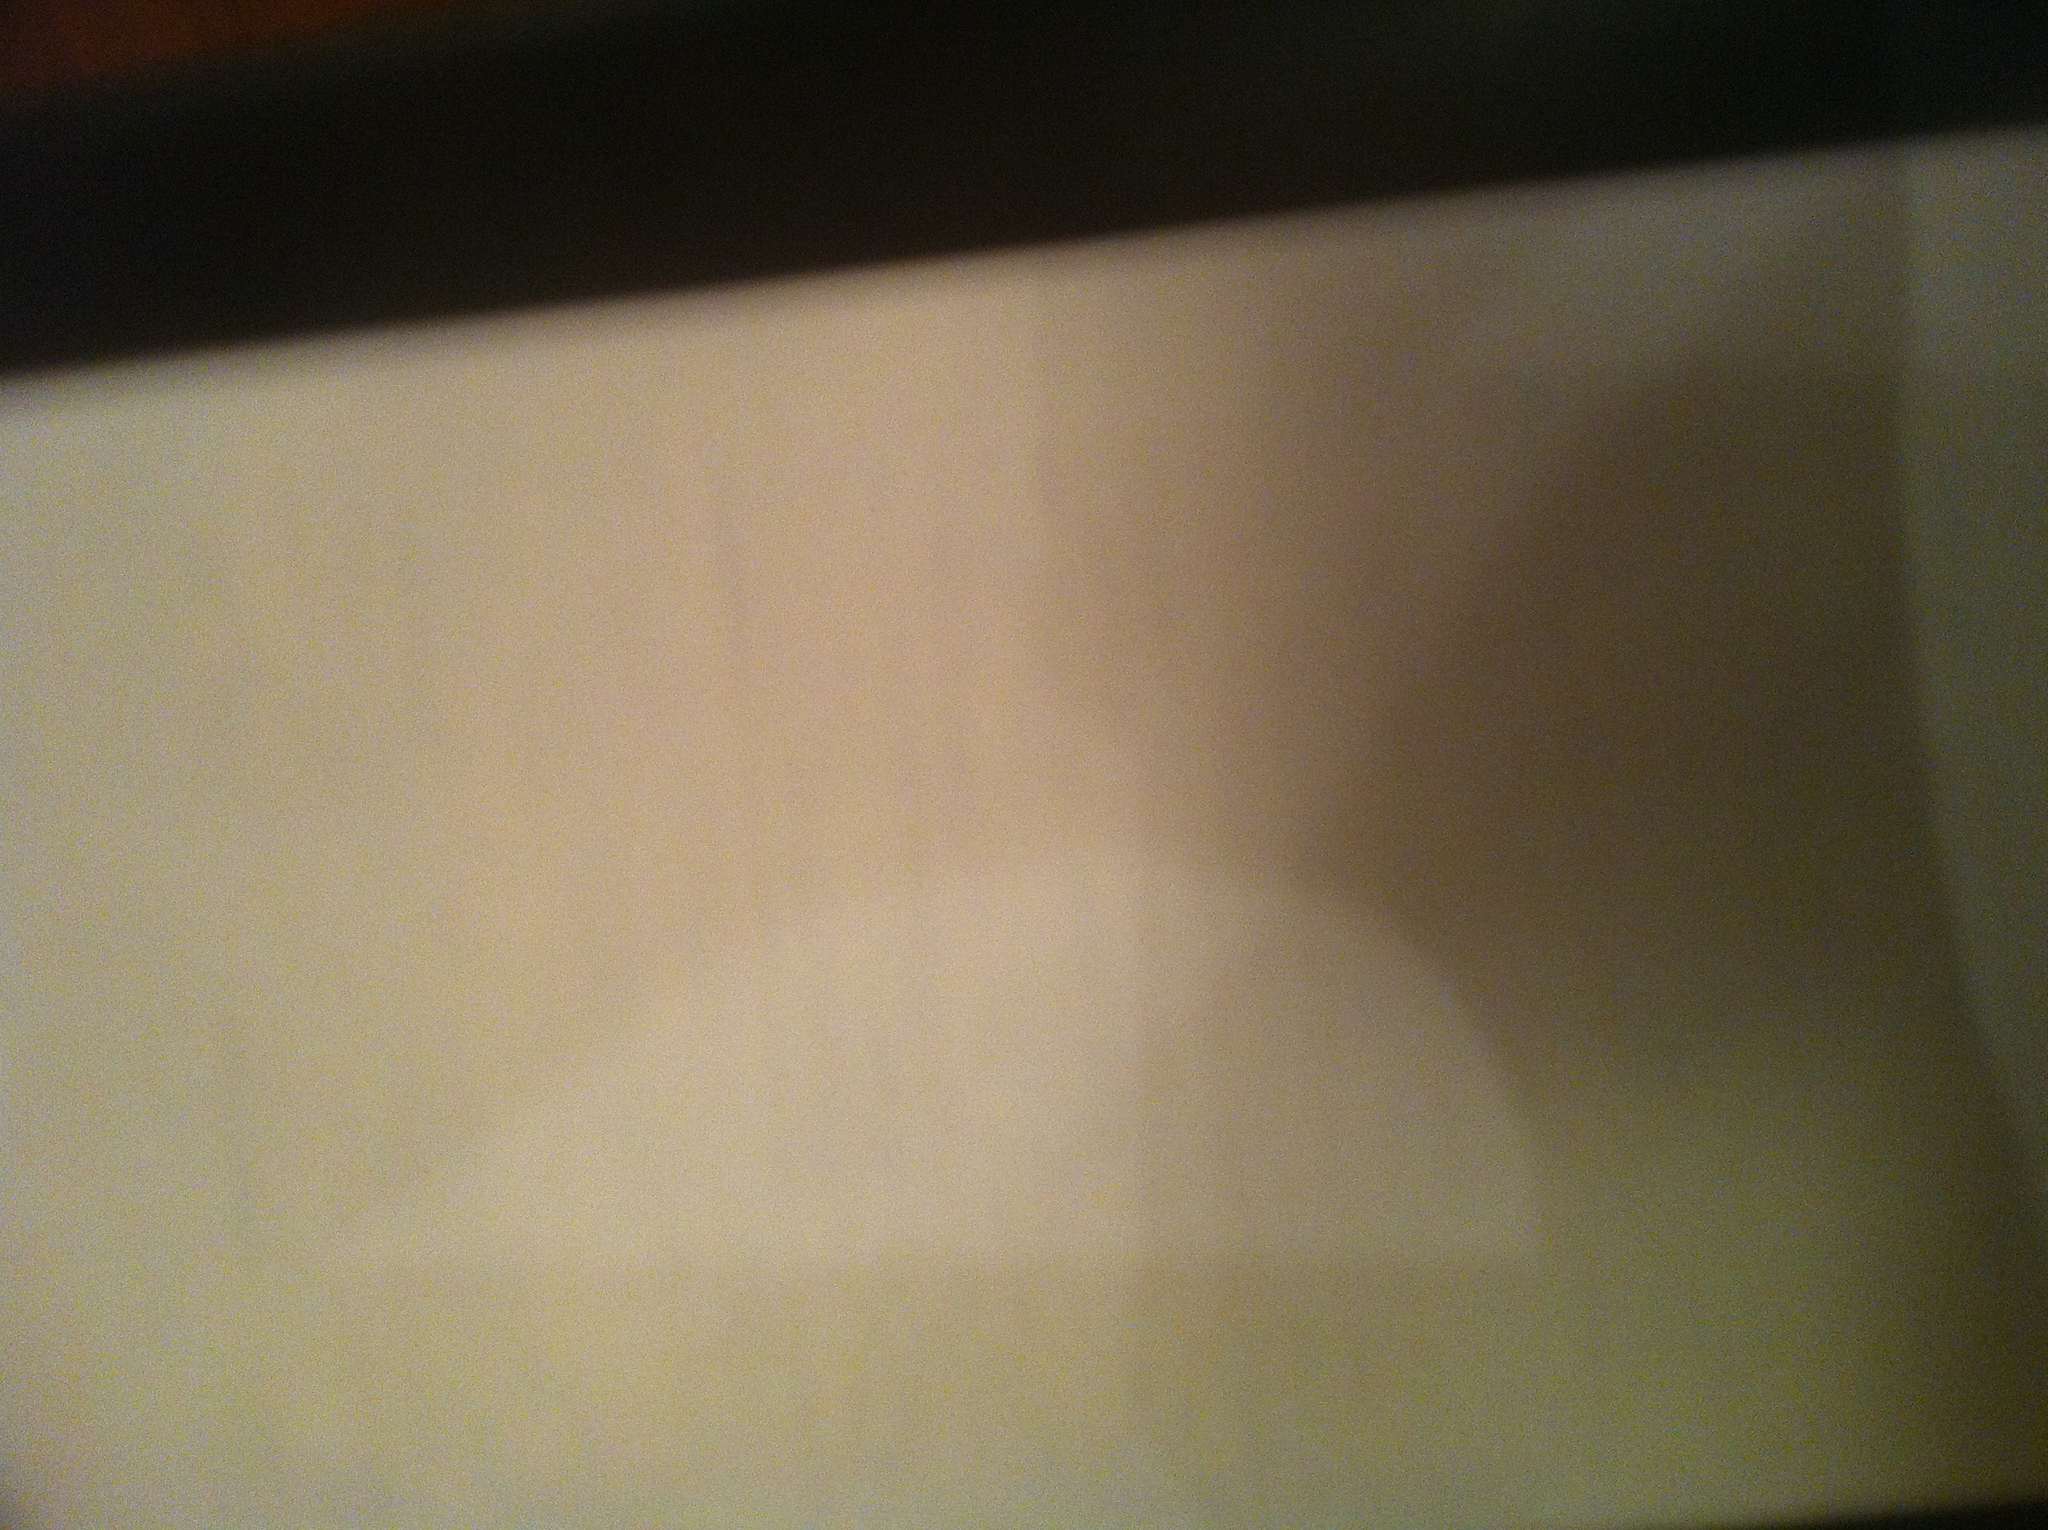What do you think the image is trying to capture? The image seems to be trying to capture the contents of a receipt or a similar document. However, the details are not clear due to the quality of the photograph. Could this be an important document? Why or why not? It could potentially be an important document if it is a receipt for a significant purchase or transaction. Receipts often contain information that is useful for returns, warranties, or expense tracking. However, without clearly seeing the content, it's impossible to confirm its importance. Create a detailed imaginary background story revolving around this image. This image could be part of a thrilling detective story. Sarah, a private investigator, was hired to expose a fraudulent business. As she combed through the trash outside their headquarters, she found this crumpled piece of paper. To the untrained eye, it seemed insignificant, but Sarah's instincts told her otherwise. She carefully straightened it and, under the right lighting, she could just make out faint imprints of numbers and letters. This was no ordinary receipt; it was a printout of a clandestine transaction, evidence that money was being laundered through an elaborate scheme. Sarah knew she was onto something big. She just needed to piece together the fragmentary clues and reveal the mastermind behind the operation. Can you generate a creative poem inspired by this image? Amid the shadowed haze it sits, a paper thin and pale,
A story veiled in mystery, a line no words entail.
The blur of ink, the ghost of print, a secret softly weeps,
Upon this fragile, silent sheet, a whispered echo sleeps.
In light and shadow it remains, a silent witness true,
What secrets do you hold, dear page, within your ghostly hue?
A tale of whispers, hidden marks, a dance of veiled intrigue,
Within your folds, the truth unfolds, though shrouded in fatigue. Imagine this document is from the future. What kind of information could it contain? If this document were from the future, it might contain fascinating insights such as transactions for futuristic items, advanced technologies, or space travel tickets. It could be part of a system that records every person's carbon footprint, contributing to a global effort to combat climate change. Alternatively, it could be an encrypted message detailing important discoveries or inventions, meant for a specific recipient whose identity is hidden within a complex code. This futuristic document might even be part of a legal framework governing interactions between humans and artificial intelligence, showcasing the evolution of society and technology. 